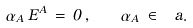<formula> <loc_0><loc_0><loc_500><loc_500>\alpha _ { A } \, E ^ { A } \, = \, 0 \, , \quad \alpha _ { A } \, \in \, \ a .</formula> 